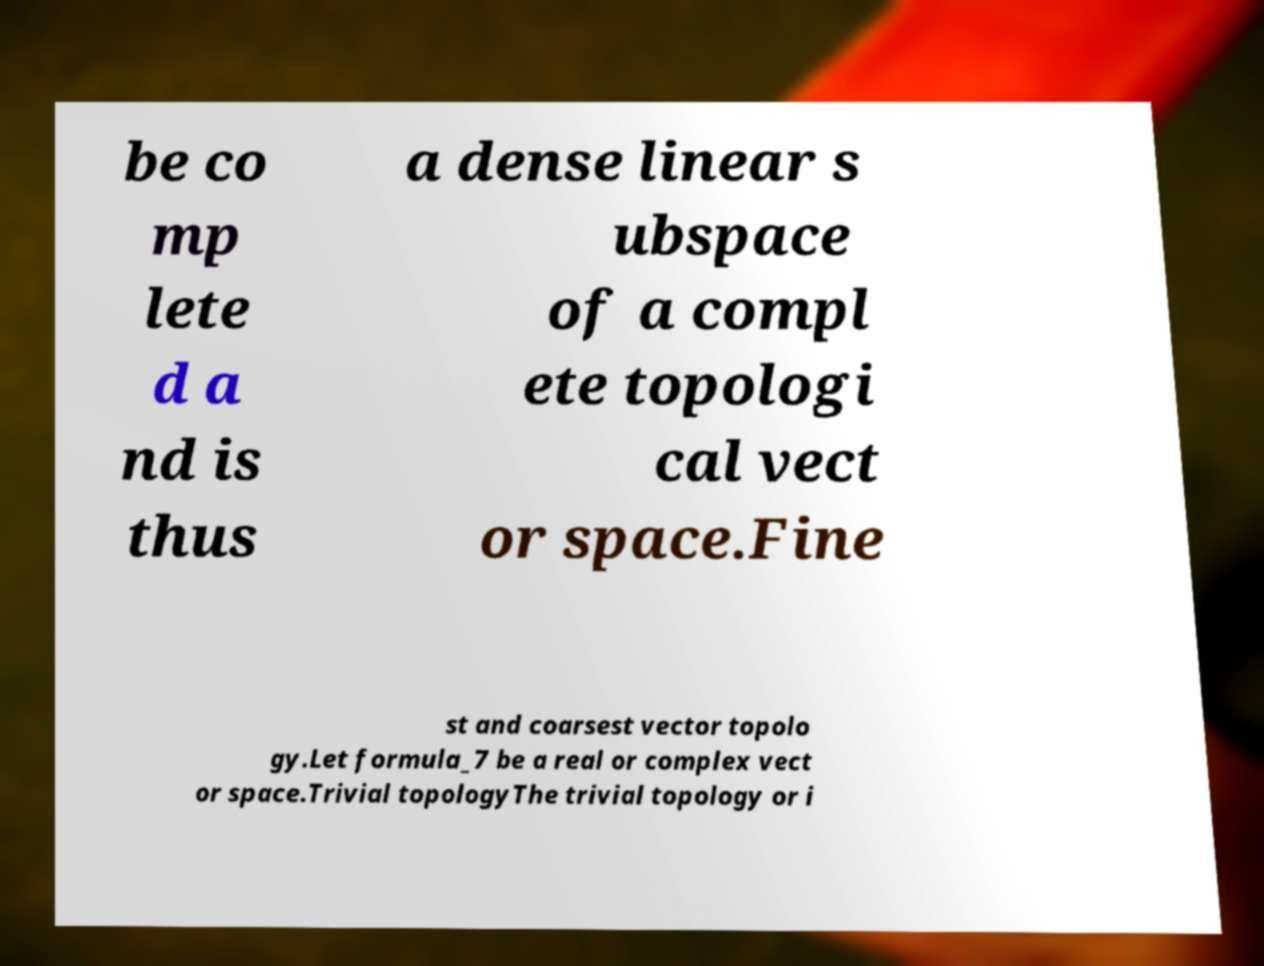What messages or text are displayed in this image? I need them in a readable, typed format. be co mp lete d a nd is thus a dense linear s ubspace of a compl ete topologi cal vect or space.Fine st and coarsest vector topolo gy.Let formula_7 be a real or complex vect or space.Trivial topologyThe trivial topology or i 